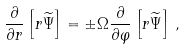Convert formula to latex. <formula><loc_0><loc_0><loc_500><loc_500>\frac { \partial } { \partial r } \left [ r \widetilde { \Psi } \right ] = \pm \Omega \frac { \partial } { \partial \varphi } \left [ r \widetilde { \Psi } \right ] \, ,</formula> 